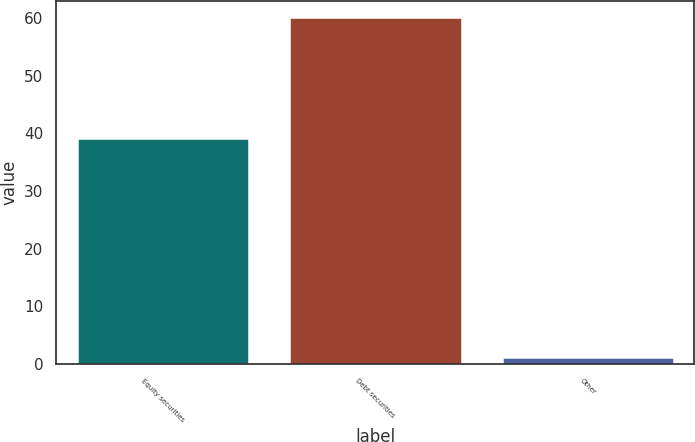<chart> <loc_0><loc_0><loc_500><loc_500><bar_chart><fcel>Equity securities<fcel>Debt securities<fcel>Other<nl><fcel>39<fcel>60<fcel>1<nl></chart> 